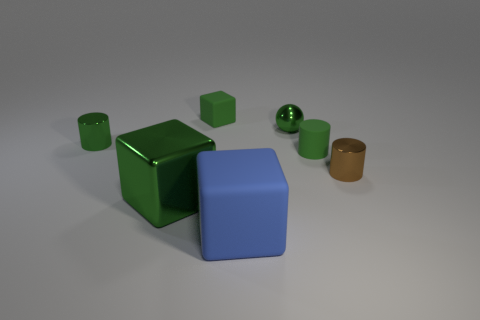Subtract all green cubes. How many were subtracted if there are1green cubes left? 1 Add 1 brown shiny things. How many objects exist? 8 Subtract all cubes. How many objects are left? 4 Subtract 0 purple cylinders. How many objects are left? 7 Subtract all balls. Subtract all big green cubes. How many objects are left? 5 Add 6 large objects. How many large objects are left? 8 Add 5 tiny cubes. How many tiny cubes exist? 6 